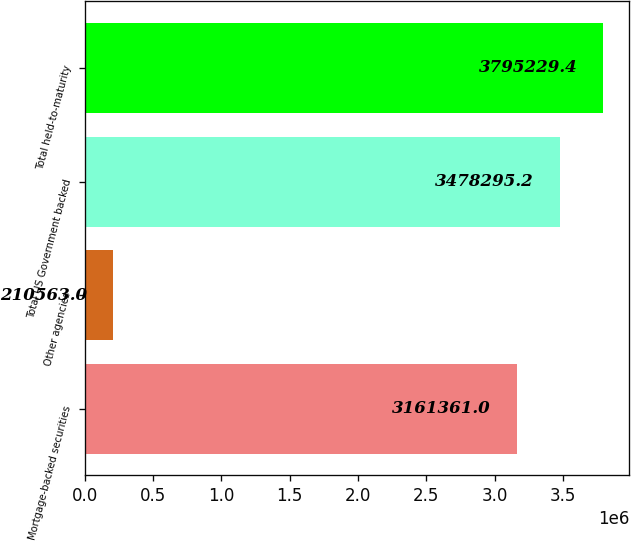<chart> <loc_0><loc_0><loc_500><loc_500><bar_chart><fcel>Mortgage-backed securities<fcel>Other agencies<fcel>Total US Government backed<fcel>Total held-to-maturity<nl><fcel>3.16136e+06<fcel>210563<fcel>3.4783e+06<fcel>3.79523e+06<nl></chart> 